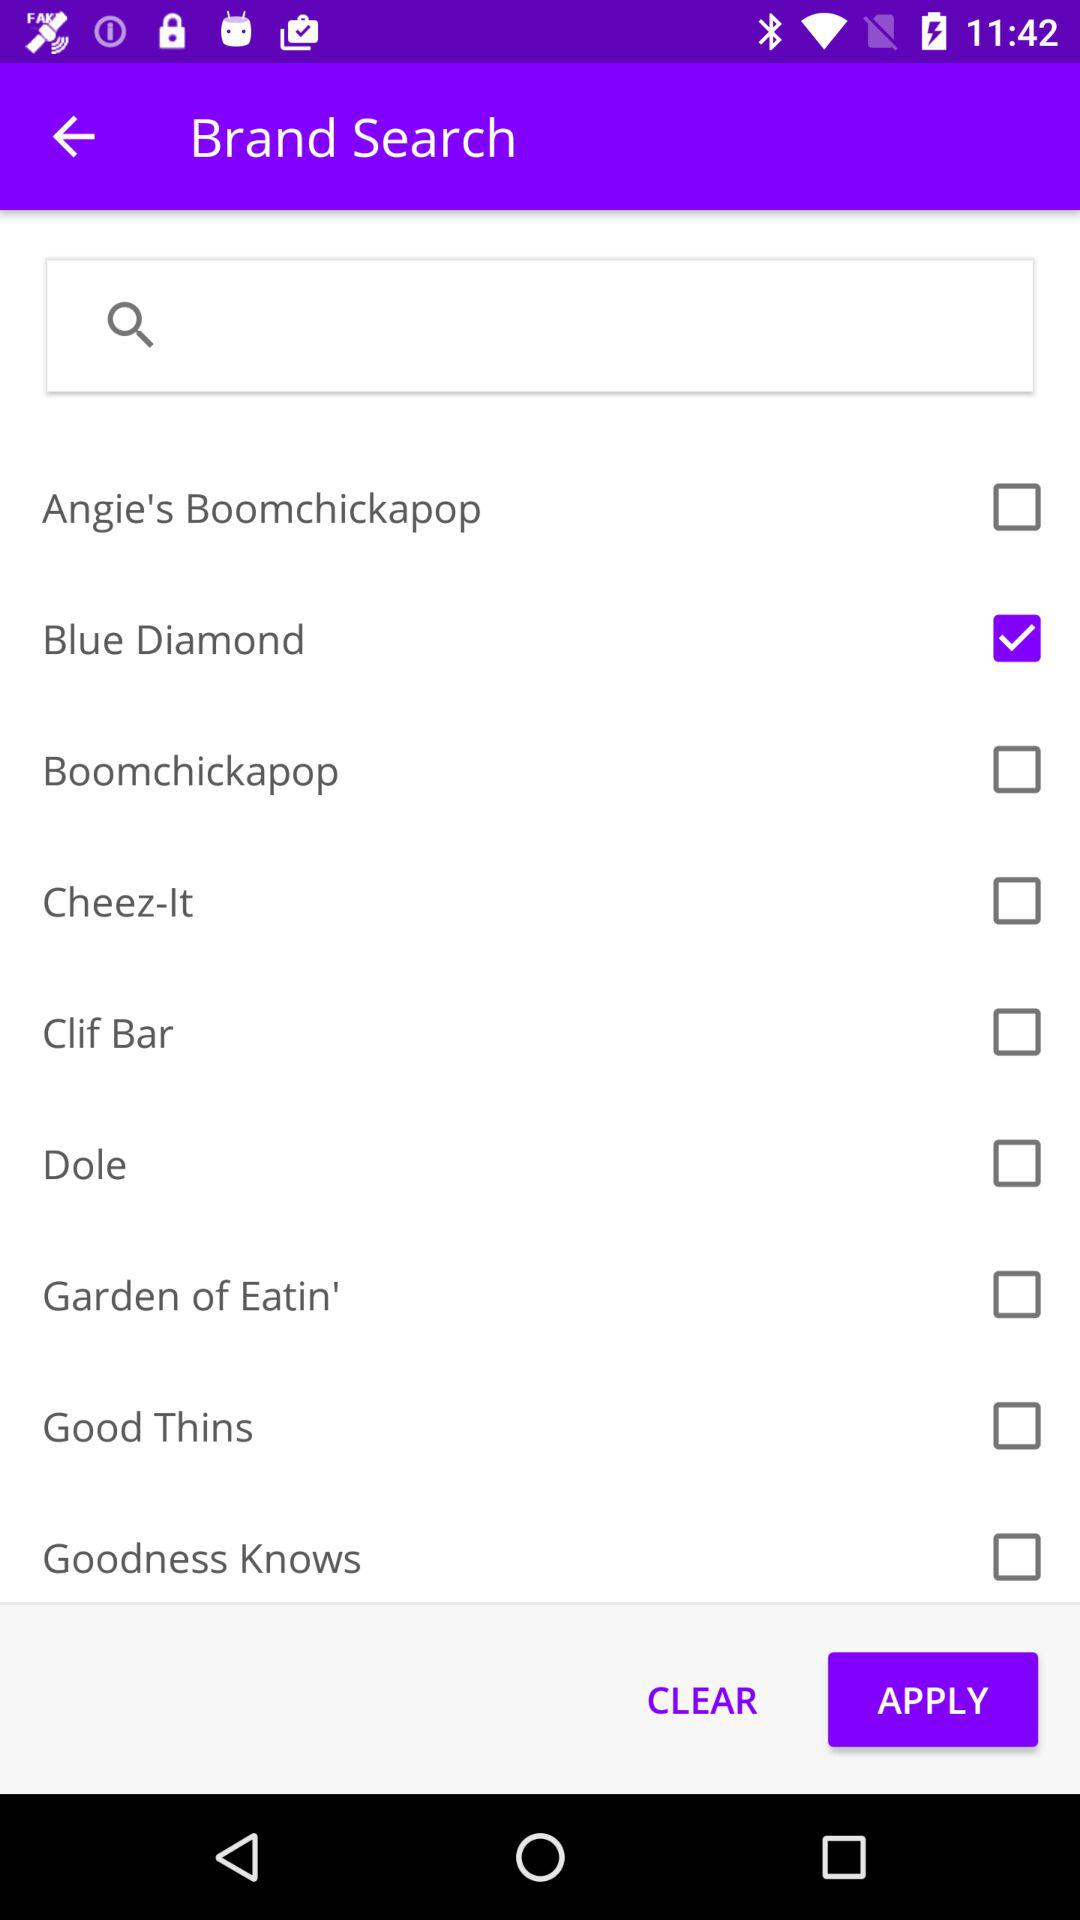Which brand is selected? The selected brand is "Blue Diamond". 